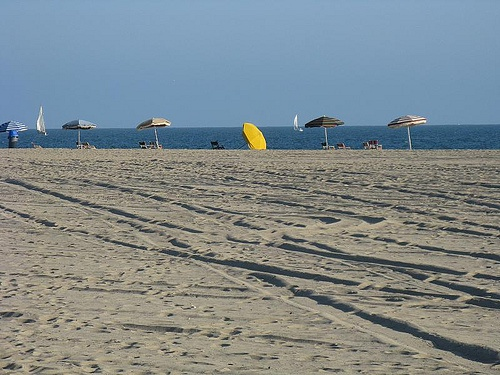Describe the objects in this image and their specific colors. I can see umbrella in darkgray, gold, and darkgreen tones, umbrella in darkgray, gray, ivory, and black tones, umbrella in darkgray, black, and gray tones, umbrella in darkgray, gray, and black tones, and umbrella in darkgray, navy, and gray tones in this image. 